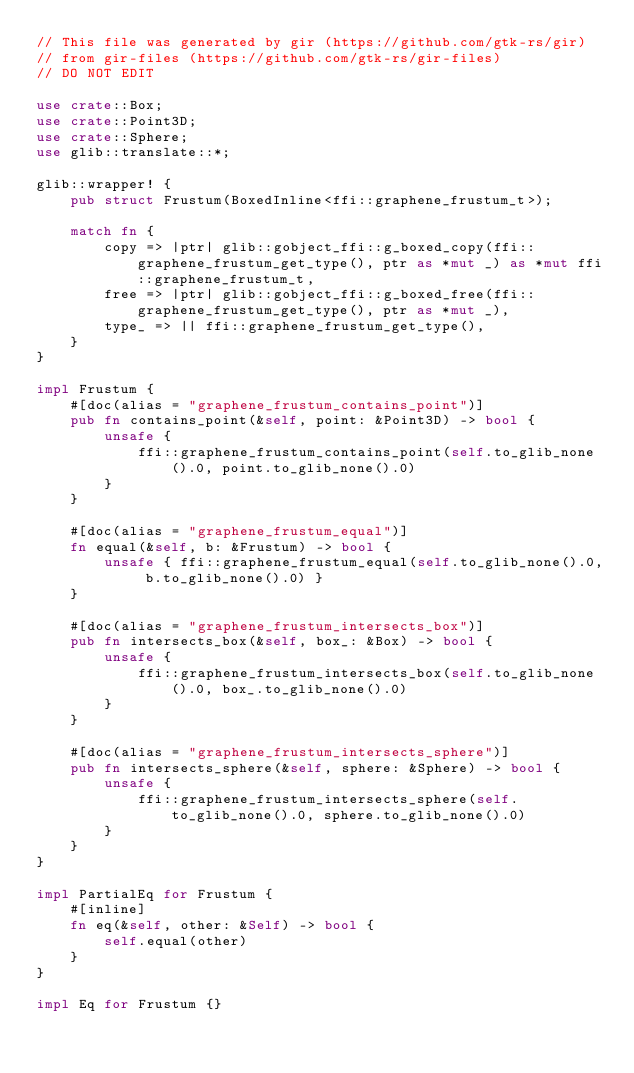Convert code to text. <code><loc_0><loc_0><loc_500><loc_500><_Rust_>// This file was generated by gir (https://github.com/gtk-rs/gir)
// from gir-files (https://github.com/gtk-rs/gir-files)
// DO NOT EDIT

use crate::Box;
use crate::Point3D;
use crate::Sphere;
use glib::translate::*;

glib::wrapper! {
    pub struct Frustum(BoxedInline<ffi::graphene_frustum_t>);

    match fn {
        copy => |ptr| glib::gobject_ffi::g_boxed_copy(ffi::graphene_frustum_get_type(), ptr as *mut _) as *mut ffi::graphene_frustum_t,
        free => |ptr| glib::gobject_ffi::g_boxed_free(ffi::graphene_frustum_get_type(), ptr as *mut _),
        type_ => || ffi::graphene_frustum_get_type(),
    }
}

impl Frustum {
    #[doc(alias = "graphene_frustum_contains_point")]
    pub fn contains_point(&self, point: &Point3D) -> bool {
        unsafe {
            ffi::graphene_frustum_contains_point(self.to_glib_none().0, point.to_glib_none().0)
        }
    }

    #[doc(alias = "graphene_frustum_equal")]
    fn equal(&self, b: &Frustum) -> bool {
        unsafe { ffi::graphene_frustum_equal(self.to_glib_none().0, b.to_glib_none().0) }
    }

    #[doc(alias = "graphene_frustum_intersects_box")]
    pub fn intersects_box(&self, box_: &Box) -> bool {
        unsafe {
            ffi::graphene_frustum_intersects_box(self.to_glib_none().0, box_.to_glib_none().0)
        }
    }

    #[doc(alias = "graphene_frustum_intersects_sphere")]
    pub fn intersects_sphere(&self, sphere: &Sphere) -> bool {
        unsafe {
            ffi::graphene_frustum_intersects_sphere(self.to_glib_none().0, sphere.to_glib_none().0)
        }
    }
}

impl PartialEq for Frustum {
    #[inline]
    fn eq(&self, other: &Self) -> bool {
        self.equal(other)
    }
}

impl Eq for Frustum {}
</code> 